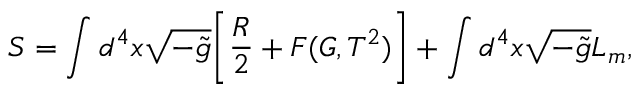Convert formula to latex. <formula><loc_0><loc_0><loc_500><loc_500>S = \int d ^ { 4 } x \sqrt { - \tilde { g } } \left [ \frac { R } { 2 } + F ( G , T ^ { 2 } ) \right ] + \int d ^ { 4 } x \sqrt { - \tilde { g } } L _ { m } ,</formula> 